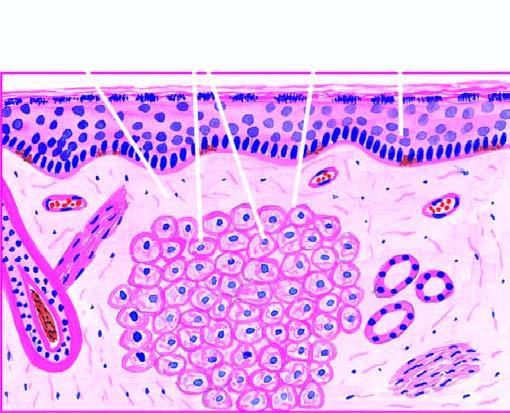s there collection of proliferating foam macrophages in the dermis with a clear subepidermal zone?
Answer the question using a single word or phrase. Yes 